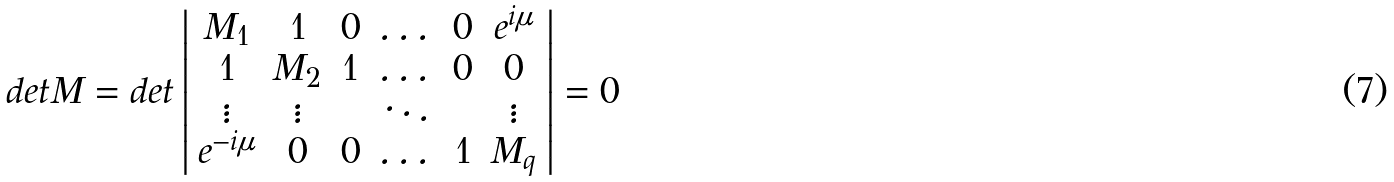<formula> <loc_0><loc_0><loc_500><loc_500>d e t M = d e t \left | \begin{array} { c c c c c c } M _ { 1 } & 1 & 0 & \dots & 0 & e ^ { i \mu } \\ 1 & M _ { 2 } & 1 & \dots & 0 & 0 \\ \vdots & \vdots & & \ddots & & \vdots \\ e ^ { - i \mu } & 0 & 0 & \dots & 1 & M _ { q } \\ \end{array} \right | = 0</formula> 